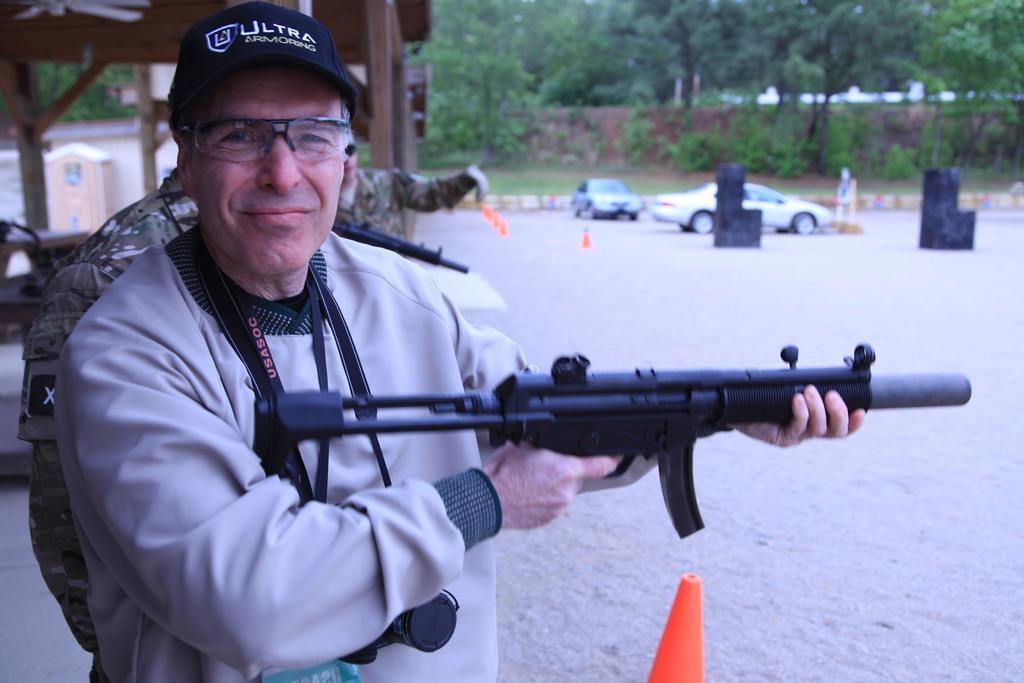Could you give a brief overview of what you see in this image? In the foreground of the picture there is a man holding a gun, behind him there are soldiers. The background is blurred. In the background there are cars, trees, plants, grass, wall, buildings and wooden roof. 